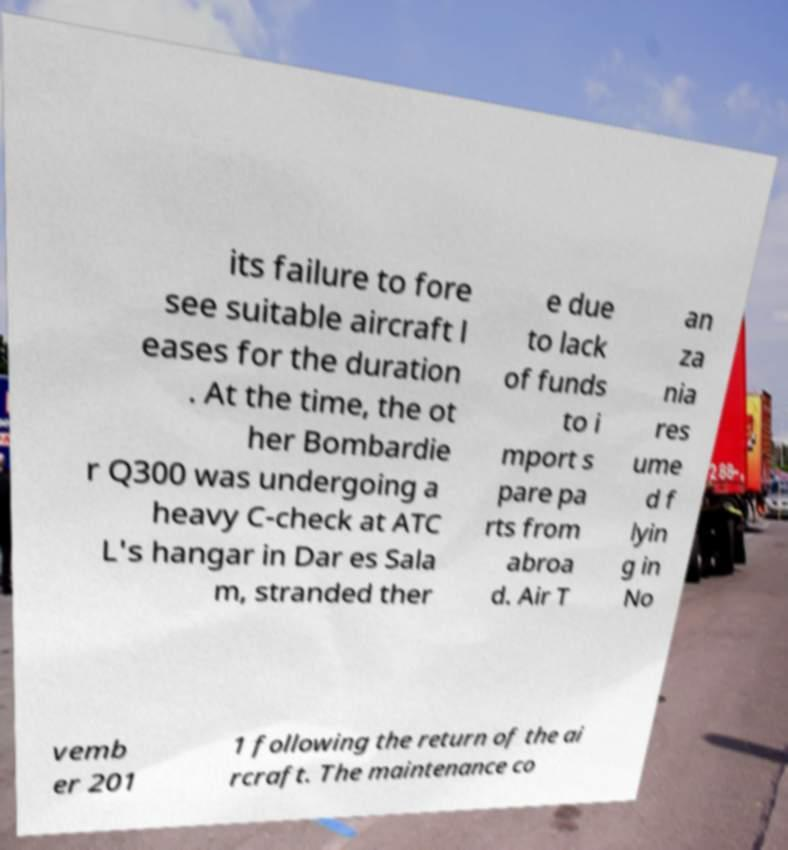What messages or text are displayed in this image? I need them in a readable, typed format. its failure to fore see suitable aircraft l eases for the duration . At the time, the ot her Bombardie r Q300 was undergoing a heavy C-check at ATC L's hangar in Dar es Sala m, stranded ther e due to lack of funds to i mport s pare pa rts from abroa d. Air T an za nia res ume d f lyin g in No vemb er 201 1 following the return of the ai rcraft. The maintenance co 